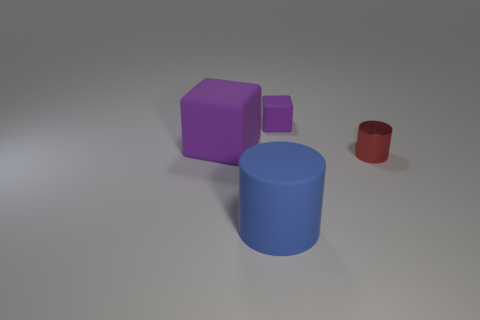Add 1 small blue metal cylinders. How many objects exist? 5 Add 4 purple rubber objects. How many purple rubber objects exist? 6 Subtract 0 gray cylinders. How many objects are left? 4 Subtract all big purple cubes. Subtract all large yellow blocks. How many objects are left? 3 Add 4 tiny purple matte objects. How many tiny purple matte objects are left? 5 